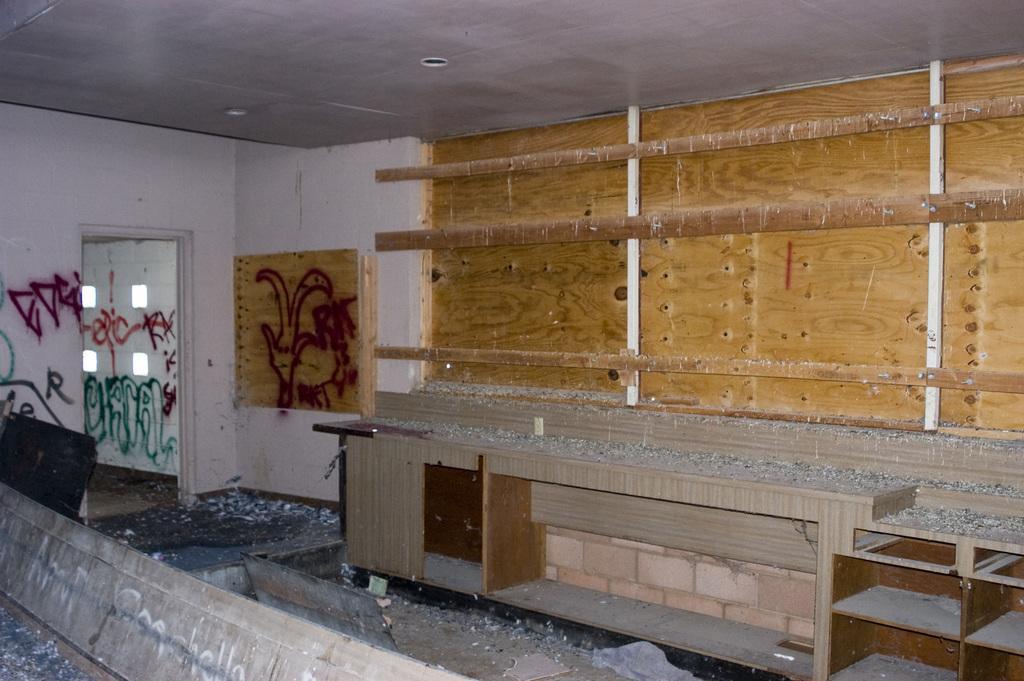Please provide a concise description of this image. This picture is an inside view of a room. In this picture we can see the graffiti on the wall and board and also we can see the cupboards, dust. At the bottom of the image we can see the floor and boards. On the board we can see the text. At the top of the image we can see the roof. On the left side of the image we can see a door. 